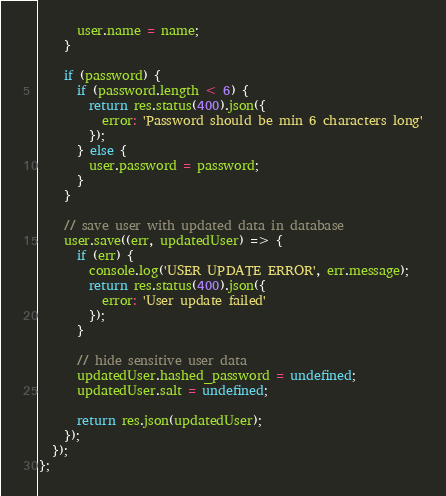<code> <loc_0><loc_0><loc_500><loc_500><_JavaScript_>      user.name = name;
    }

    if (password) {
      if (password.length < 6) {
        return res.status(400).json({
          error: 'Password should be min 6 characters long'
        });
      } else {
        user.password = password;
      }
    }

    // save user with updated data in database
    user.save((err, updatedUser) => {
      if (err) {
        console.log('USER UPDATE ERROR', err.message);
        return res.status(400).json({
          error: 'User update failed'
        });
      }

      // hide sensitive user data
      updatedUser.hashed_password = undefined;
      updatedUser.salt = undefined;

      return res.json(updatedUser);
    });
  });
};
</code> 